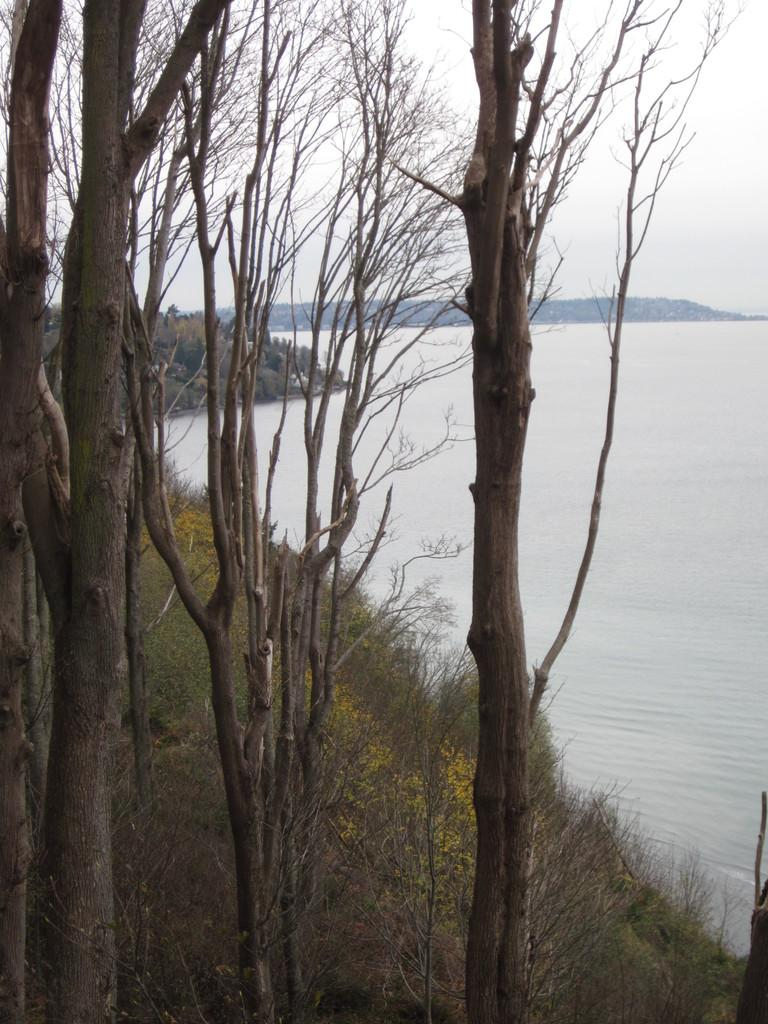What type of natural environment is depicted in the image? The image features a sea and a sky, indicating a coastal or beach setting. What type of vegetation can be seen in the image? There are many plants and trees visible in the image. Can you describe the sky in the image? The sky is visible in the image, but no specific details about its appearance are provided. What is the name of the person who destroyed the flowers in the image? There is no person, destruction, name, or flowers mentioned in the image or the provided facts. 